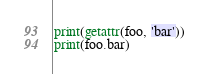Convert code to text. <code><loc_0><loc_0><loc_500><loc_500><_Python_>print(getattr(foo, 'bar'))
print(foo.bar)
</code> 